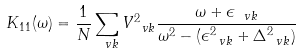Convert formula to latex. <formula><loc_0><loc_0><loc_500><loc_500>K _ { 1 1 } ( \omega ) = \frac { 1 } { N } \sum _ { \ v k } V _ { \ v k } ^ { 2 } \frac { \omega + \epsilon _ { \ v k } } { \omega ^ { 2 } - ( \epsilon _ { \ v k } ^ { 2 } + \Delta _ { \ v k } ^ { 2 } ) }</formula> 